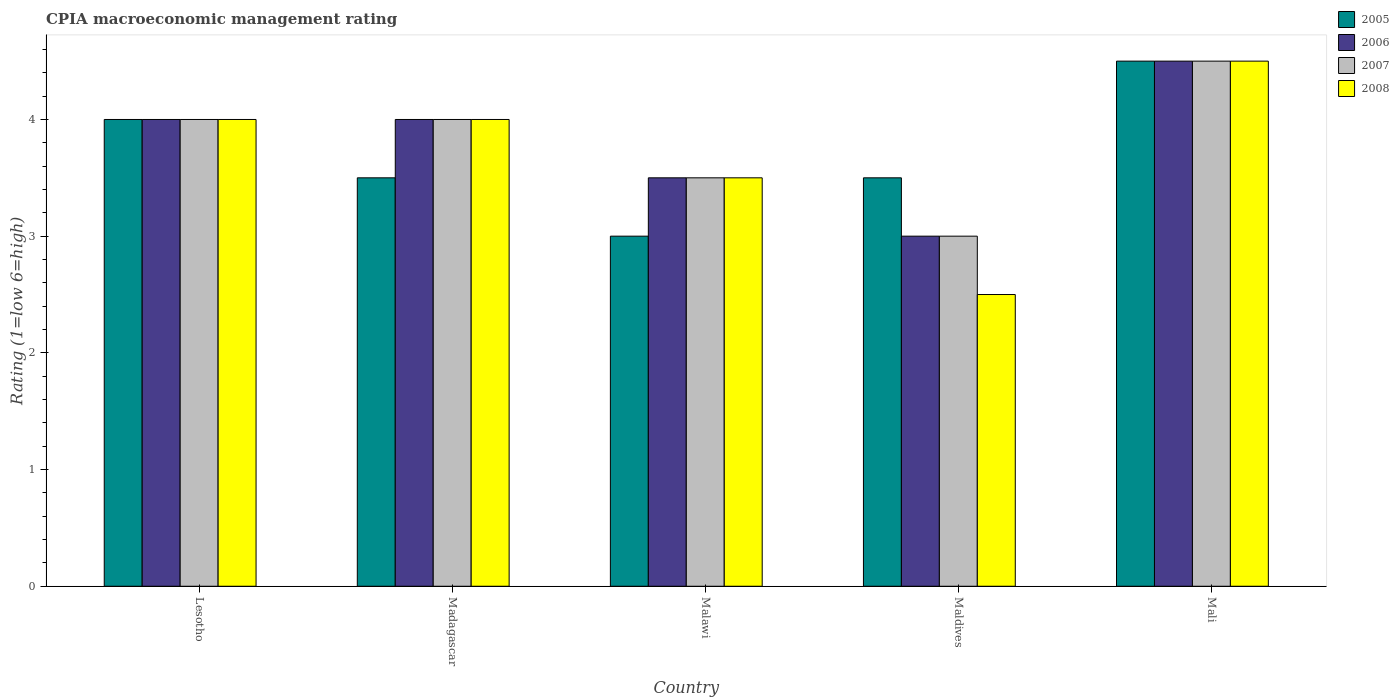How many groups of bars are there?
Provide a succinct answer. 5. Are the number of bars per tick equal to the number of legend labels?
Your response must be concise. Yes. Are the number of bars on each tick of the X-axis equal?
Ensure brevity in your answer.  Yes. How many bars are there on the 3rd tick from the left?
Offer a terse response. 4. What is the label of the 3rd group of bars from the left?
Your answer should be very brief. Malawi. What is the CPIA rating in 2007 in Madagascar?
Give a very brief answer. 4. Across all countries, what is the maximum CPIA rating in 2005?
Ensure brevity in your answer.  4.5. In which country was the CPIA rating in 2007 maximum?
Offer a terse response. Mali. In which country was the CPIA rating in 2006 minimum?
Give a very brief answer. Maldives. What is the total CPIA rating in 2008 in the graph?
Ensure brevity in your answer.  18.5. What is the difference between the CPIA rating of/in 2005 and CPIA rating of/in 2008 in Malawi?
Offer a terse response. -0.5. What is the ratio of the CPIA rating in 2005 in Maldives to that in Mali?
Offer a terse response. 0.78. In how many countries, is the CPIA rating in 2006 greater than the average CPIA rating in 2006 taken over all countries?
Offer a terse response. 3. Is the sum of the CPIA rating in 2007 in Maldives and Mali greater than the maximum CPIA rating in 2005 across all countries?
Offer a terse response. Yes. What does the 1st bar from the left in Mali represents?
Provide a short and direct response. 2005. Are all the bars in the graph horizontal?
Give a very brief answer. No. How many countries are there in the graph?
Make the answer very short. 5. What is the difference between two consecutive major ticks on the Y-axis?
Give a very brief answer. 1. Does the graph contain any zero values?
Provide a short and direct response. No. Where does the legend appear in the graph?
Provide a succinct answer. Top right. What is the title of the graph?
Provide a short and direct response. CPIA macroeconomic management rating. Does "2002" appear as one of the legend labels in the graph?
Offer a very short reply. No. What is the Rating (1=low 6=high) in 2005 in Lesotho?
Offer a terse response. 4. What is the Rating (1=low 6=high) in 2007 in Lesotho?
Make the answer very short. 4. What is the Rating (1=low 6=high) of 2006 in Madagascar?
Give a very brief answer. 4. What is the Rating (1=low 6=high) in 2005 in Malawi?
Provide a short and direct response. 3. What is the Rating (1=low 6=high) in 2006 in Malawi?
Ensure brevity in your answer.  3.5. What is the Rating (1=low 6=high) in 2008 in Malawi?
Make the answer very short. 3.5. What is the Rating (1=low 6=high) in 2008 in Maldives?
Your answer should be compact. 2.5. What is the Rating (1=low 6=high) in 2005 in Mali?
Your answer should be very brief. 4.5. What is the Rating (1=low 6=high) in 2008 in Mali?
Make the answer very short. 4.5. Across all countries, what is the maximum Rating (1=low 6=high) in 2005?
Provide a short and direct response. 4.5. Across all countries, what is the maximum Rating (1=low 6=high) in 2007?
Give a very brief answer. 4.5. Across all countries, what is the maximum Rating (1=low 6=high) in 2008?
Keep it short and to the point. 4.5. Across all countries, what is the minimum Rating (1=low 6=high) in 2005?
Your response must be concise. 3. Across all countries, what is the minimum Rating (1=low 6=high) of 2008?
Provide a succinct answer. 2.5. What is the total Rating (1=low 6=high) in 2005 in the graph?
Provide a succinct answer. 18.5. What is the total Rating (1=low 6=high) of 2007 in the graph?
Make the answer very short. 19. What is the difference between the Rating (1=low 6=high) in 2005 in Lesotho and that in Madagascar?
Your answer should be compact. 0.5. What is the difference between the Rating (1=low 6=high) of 2008 in Lesotho and that in Madagascar?
Your response must be concise. 0. What is the difference between the Rating (1=low 6=high) in 2007 in Lesotho and that in Malawi?
Provide a succinct answer. 0.5. What is the difference between the Rating (1=low 6=high) in 2005 in Lesotho and that in Maldives?
Ensure brevity in your answer.  0.5. What is the difference between the Rating (1=low 6=high) of 2006 in Lesotho and that in Maldives?
Make the answer very short. 1. What is the difference between the Rating (1=low 6=high) in 2006 in Madagascar and that in Malawi?
Give a very brief answer. 0.5. What is the difference between the Rating (1=low 6=high) of 2008 in Madagascar and that in Malawi?
Give a very brief answer. 0.5. What is the difference between the Rating (1=low 6=high) in 2005 in Madagascar and that in Maldives?
Provide a succinct answer. 0. What is the difference between the Rating (1=low 6=high) in 2008 in Madagascar and that in Mali?
Provide a succinct answer. -0.5. What is the difference between the Rating (1=low 6=high) of 2008 in Malawi and that in Maldives?
Provide a succinct answer. 1. What is the difference between the Rating (1=low 6=high) in 2006 in Malawi and that in Mali?
Your response must be concise. -1. What is the difference between the Rating (1=low 6=high) of 2008 in Malawi and that in Mali?
Your answer should be compact. -1. What is the difference between the Rating (1=low 6=high) in 2006 in Maldives and that in Mali?
Give a very brief answer. -1.5. What is the difference between the Rating (1=low 6=high) of 2005 in Lesotho and the Rating (1=low 6=high) of 2006 in Madagascar?
Offer a very short reply. 0. What is the difference between the Rating (1=low 6=high) in 2005 in Lesotho and the Rating (1=low 6=high) in 2007 in Madagascar?
Provide a succinct answer. 0. What is the difference between the Rating (1=low 6=high) of 2007 in Lesotho and the Rating (1=low 6=high) of 2008 in Madagascar?
Make the answer very short. 0. What is the difference between the Rating (1=low 6=high) in 2005 in Lesotho and the Rating (1=low 6=high) in 2007 in Malawi?
Offer a very short reply. 0.5. What is the difference between the Rating (1=low 6=high) in 2006 in Lesotho and the Rating (1=low 6=high) in 2007 in Malawi?
Provide a succinct answer. 0.5. What is the difference between the Rating (1=low 6=high) in 2005 in Lesotho and the Rating (1=low 6=high) in 2006 in Maldives?
Offer a terse response. 1. What is the difference between the Rating (1=low 6=high) of 2005 in Lesotho and the Rating (1=low 6=high) of 2008 in Maldives?
Offer a very short reply. 1.5. What is the difference between the Rating (1=low 6=high) in 2007 in Lesotho and the Rating (1=low 6=high) in 2008 in Maldives?
Provide a succinct answer. 1.5. What is the difference between the Rating (1=low 6=high) in 2005 in Lesotho and the Rating (1=low 6=high) in 2006 in Mali?
Provide a succinct answer. -0.5. What is the difference between the Rating (1=low 6=high) in 2005 in Lesotho and the Rating (1=low 6=high) in 2007 in Mali?
Offer a very short reply. -0.5. What is the difference between the Rating (1=low 6=high) in 2005 in Lesotho and the Rating (1=low 6=high) in 2008 in Mali?
Provide a succinct answer. -0.5. What is the difference between the Rating (1=low 6=high) in 2006 in Lesotho and the Rating (1=low 6=high) in 2007 in Mali?
Ensure brevity in your answer.  -0.5. What is the difference between the Rating (1=low 6=high) in 2007 in Lesotho and the Rating (1=low 6=high) in 2008 in Mali?
Your answer should be compact. -0.5. What is the difference between the Rating (1=low 6=high) in 2005 in Madagascar and the Rating (1=low 6=high) in 2006 in Malawi?
Give a very brief answer. 0. What is the difference between the Rating (1=low 6=high) in 2005 in Madagascar and the Rating (1=low 6=high) in 2008 in Malawi?
Provide a succinct answer. 0. What is the difference between the Rating (1=low 6=high) of 2006 in Madagascar and the Rating (1=low 6=high) of 2008 in Malawi?
Provide a succinct answer. 0.5. What is the difference between the Rating (1=low 6=high) of 2005 in Madagascar and the Rating (1=low 6=high) of 2006 in Maldives?
Keep it short and to the point. 0.5. What is the difference between the Rating (1=low 6=high) in 2005 in Madagascar and the Rating (1=low 6=high) in 2007 in Maldives?
Your response must be concise. 0.5. What is the difference between the Rating (1=low 6=high) of 2006 in Madagascar and the Rating (1=low 6=high) of 2008 in Maldives?
Offer a terse response. 1.5. What is the difference between the Rating (1=low 6=high) in 2007 in Madagascar and the Rating (1=low 6=high) in 2008 in Maldives?
Make the answer very short. 1.5. What is the difference between the Rating (1=low 6=high) of 2005 in Madagascar and the Rating (1=low 6=high) of 2007 in Mali?
Make the answer very short. -1. What is the difference between the Rating (1=low 6=high) in 2006 in Madagascar and the Rating (1=low 6=high) in 2007 in Mali?
Offer a very short reply. -0.5. What is the difference between the Rating (1=low 6=high) of 2006 in Madagascar and the Rating (1=low 6=high) of 2008 in Mali?
Offer a very short reply. -0.5. What is the difference between the Rating (1=low 6=high) in 2005 in Malawi and the Rating (1=low 6=high) in 2006 in Maldives?
Ensure brevity in your answer.  0. What is the difference between the Rating (1=low 6=high) of 2006 in Malawi and the Rating (1=low 6=high) of 2007 in Maldives?
Ensure brevity in your answer.  0.5. What is the difference between the Rating (1=low 6=high) of 2006 in Malawi and the Rating (1=low 6=high) of 2008 in Maldives?
Make the answer very short. 1. What is the difference between the Rating (1=low 6=high) of 2007 in Malawi and the Rating (1=low 6=high) of 2008 in Maldives?
Offer a terse response. 1. What is the difference between the Rating (1=low 6=high) of 2005 in Malawi and the Rating (1=low 6=high) of 2007 in Mali?
Ensure brevity in your answer.  -1.5. What is the difference between the Rating (1=low 6=high) in 2006 in Malawi and the Rating (1=low 6=high) in 2007 in Mali?
Give a very brief answer. -1. What is the difference between the Rating (1=low 6=high) in 2005 in Maldives and the Rating (1=low 6=high) in 2006 in Mali?
Offer a very short reply. -1. What is the difference between the Rating (1=low 6=high) in 2005 in Maldives and the Rating (1=low 6=high) in 2007 in Mali?
Your answer should be very brief. -1. What is the difference between the Rating (1=low 6=high) of 2006 in Maldives and the Rating (1=low 6=high) of 2007 in Mali?
Ensure brevity in your answer.  -1.5. What is the difference between the Rating (1=low 6=high) of 2006 in Maldives and the Rating (1=low 6=high) of 2008 in Mali?
Offer a terse response. -1.5. What is the average Rating (1=low 6=high) in 2005 per country?
Your answer should be very brief. 3.7. What is the average Rating (1=low 6=high) in 2006 per country?
Your answer should be very brief. 3.8. What is the average Rating (1=low 6=high) of 2007 per country?
Provide a succinct answer. 3.8. What is the average Rating (1=low 6=high) of 2008 per country?
Your answer should be very brief. 3.7. What is the difference between the Rating (1=low 6=high) in 2005 and Rating (1=low 6=high) in 2006 in Lesotho?
Your answer should be very brief. 0. What is the difference between the Rating (1=low 6=high) of 2005 and Rating (1=low 6=high) of 2008 in Lesotho?
Offer a very short reply. 0. What is the difference between the Rating (1=low 6=high) in 2006 and Rating (1=low 6=high) in 2007 in Lesotho?
Ensure brevity in your answer.  0. What is the difference between the Rating (1=low 6=high) in 2006 and Rating (1=low 6=high) in 2008 in Lesotho?
Your answer should be very brief. 0. What is the difference between the Rating (1=low 6=high) of 2007 and Rating (1=low 6=high) of 2008 in Lesotho?
Keep it short and to the point. 0. What is the difference between the Rating (1=low 6=high) in 2005 and Rating (1=low 6=high) in 2006 in Madagascar?
Your response must be concise. -0.5. What is the difference between the Rating (1=low 6=high) in 2005 and Rating (1=low 6=high) in 2008 in Madagascar?
Provide a short and direct response. -0.5. What is the difference between the Rating (1=low 6=high) in 2006 and Rating (1=low 6=high) in 2008 in Madagascar?
Ensure brevity in your answer.  0. What is the difference between the Rating (1=low 6=high) in 2005 and Rating (1=low 6=high) in 2006 in Malawi?
Provide a short and direct response. -0.5. What is the difference between the Rating (1=low 6=high) in 2005 and Rating (1=low 6=high) in 2007 in Malawi?
Your response must be concise. -0.5. What is the difference between the Rating (1=low 6=high) of 2006 and Rating (1=low 6=high) of 2007 in Malawi?
Give a very brief answer. 0. What is the difference between the Rating (1=low 6=high) of 2006 and Rating (1=low 6=high) of 2008 in Malawi?
Keep it short and to the point. 0. What is the difference between the Rating (1=low 6=high) of 2005 and Rating (1=low 6=high) of 2007 in Maldives?
Your answer should be compact. 0.5. What is the difference between the Rating (1=low 6=high) of 2005 and Rating (1=low 6=high) of 2008 in Maldives?
Offer a very short reply. 1. What is the difference between the Rating (1=low 6=high) of 2006 and Rating (1=low 6=high) of 2008 in Maldives?
Make the answer very short. 0.5. What is the difference between the Rating (1=low 6=high) of 2005 and Rating (1=low 6=high) of 2006 in Mali?
Your answer should be compact. 0. What is the ratio of the Rating (1=low 6=high) of 2007 in Lesotho to that in Madagascar?
Offer a very short reply. 1. What is the ratio of the Rating (1=low 6=high) of 2005 in Lesotho to that in Malawi?
Your response must be concise. 1.33. What is the ratio of the Rating (1=low 6=high) in 2007 in Lesotho to that in Malawi?
Your answer should be very brief. 1.14. What is the ratio of the Rating (1=low 6=high) of 2008 in Lesotho to that in Malawi?
Your response must be concise. 1.14. What is the ratio of the Rating (1=low 6=high) in 2007 in Lesotho to that in Mali?
Your answer should be compact. 0.89. What is the ratio of the Rating (1=low 6=high) in 2008 in Lesotho to that in Mali?
Your answer should be very brief. 0.89. What is the ratio of the Rating (1=low 6=high) in 2005 in Madagascar to that in Malawi?
Ensure brevity in your answer.  1.17. What is the ratio of the Rating (1=low 6=high) of 2006 in Madagascar to that in Malawi?
Make the answer very short. 1.14. What is the ratio of the Rating (1=low 6=high) of 2008 in Madagascar to that in Malawi?
Your response must be concise. 1.14. What is the ratio of the Rating (1=low 6=high) of 2007 in Madagascar to that in Maldives?
Provide a succinct answer. 1.33. What is the ratio of the Rating (1=low 6=high) in 2008 in Madagascar to that in Maldives?
Your response must be concise. 1.6. What is the ratio of the Rating (1=low 6=high) of 2005 in Malawi to that in Maldives?
Your response must be concise. 0.86. What is the ratio of the Rating (1=low 6=high) of 2006 in Malawi to that in Maldives?
Your answer should be very brief. 1.17. What is the ratio of the Rating (1=low 6=high) in 2007 in Malawi to that in Maldives?
Your response must be concise. 1.17. What is the ratio of the Rating (1=low 6=high) in 2005 in Malawi to that in Mali?
Provide a short and direct response. 0.67. What is the ratio of the Rating (1=low 6=high) in 2007 in Malawi to that in Mali?
Your answer should be compact. 0.78. What is the ratio of the Rating (1=low 6=high) in 2008 in Malawi to that in Mali?
Keep it short and to the point. 0.78. What is the ratio of the Rating (1=low 6=high) in 2005 in Maldives to that in Mali?
Your answer should be very brief. 0.78. What is the ratio of the Rating (1=low 6=high) in 2007 in Maldives to that in Mali?
Your response must be concise. 0.67. What is the ratio of the Rating (1=low 6=high) in 2008 in Maldives to that in Mali?
Offer a terse response. 0.56. What is the difference between the highest and the second highest Rating (1=low 6=high) in 2006?
Your response must be concise. 0.5. What is the difference between the highest and the lowest Rating (1=low 6=high) of 2005?
Provide a succinct answer. 1.5. What is the difference between the highest and the lowest Rating (1=low 6=high) in 2007?
Your response must be concise. 1.5. 